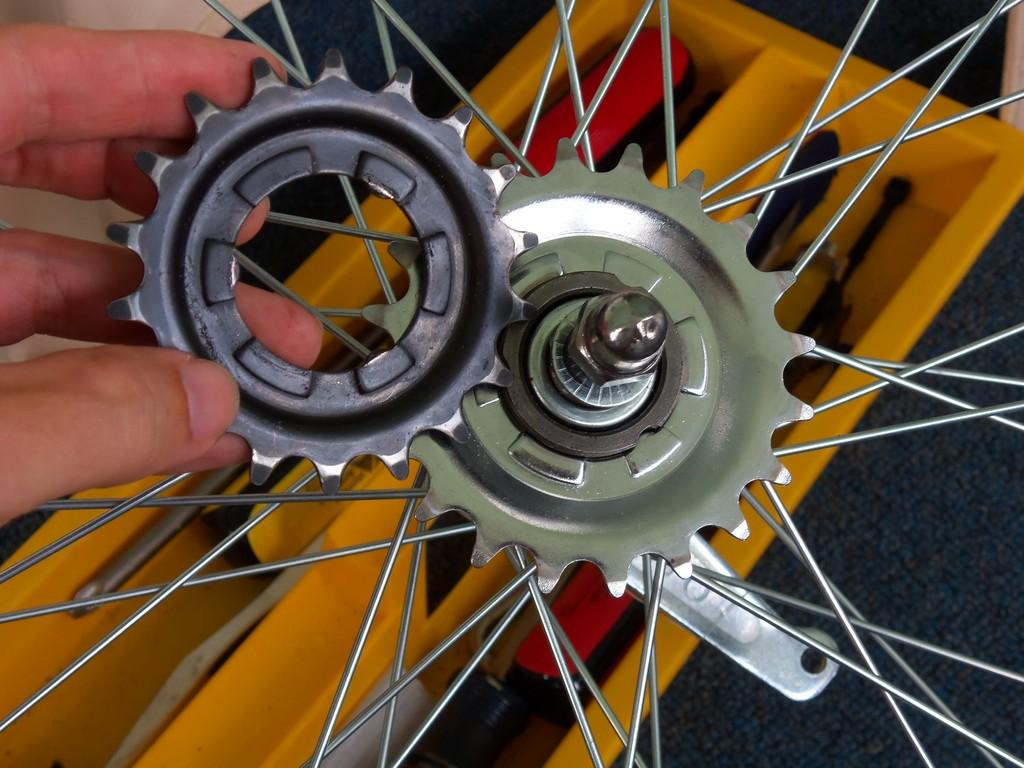What is the main object in the image? There is a wheel in the image. What feature can be seen on the wheel? There are rims on the wheel. What else is present in the image besides the wheel? There is a yellow color tool kit in the image. Can you describe the human presence in the image? A human hand is visible on the left side of the image. What type of collar is being used to test the wheel in the image? There is no collar or testing activity present in the image; it features a wheel with rims and a yellow tool kit. 